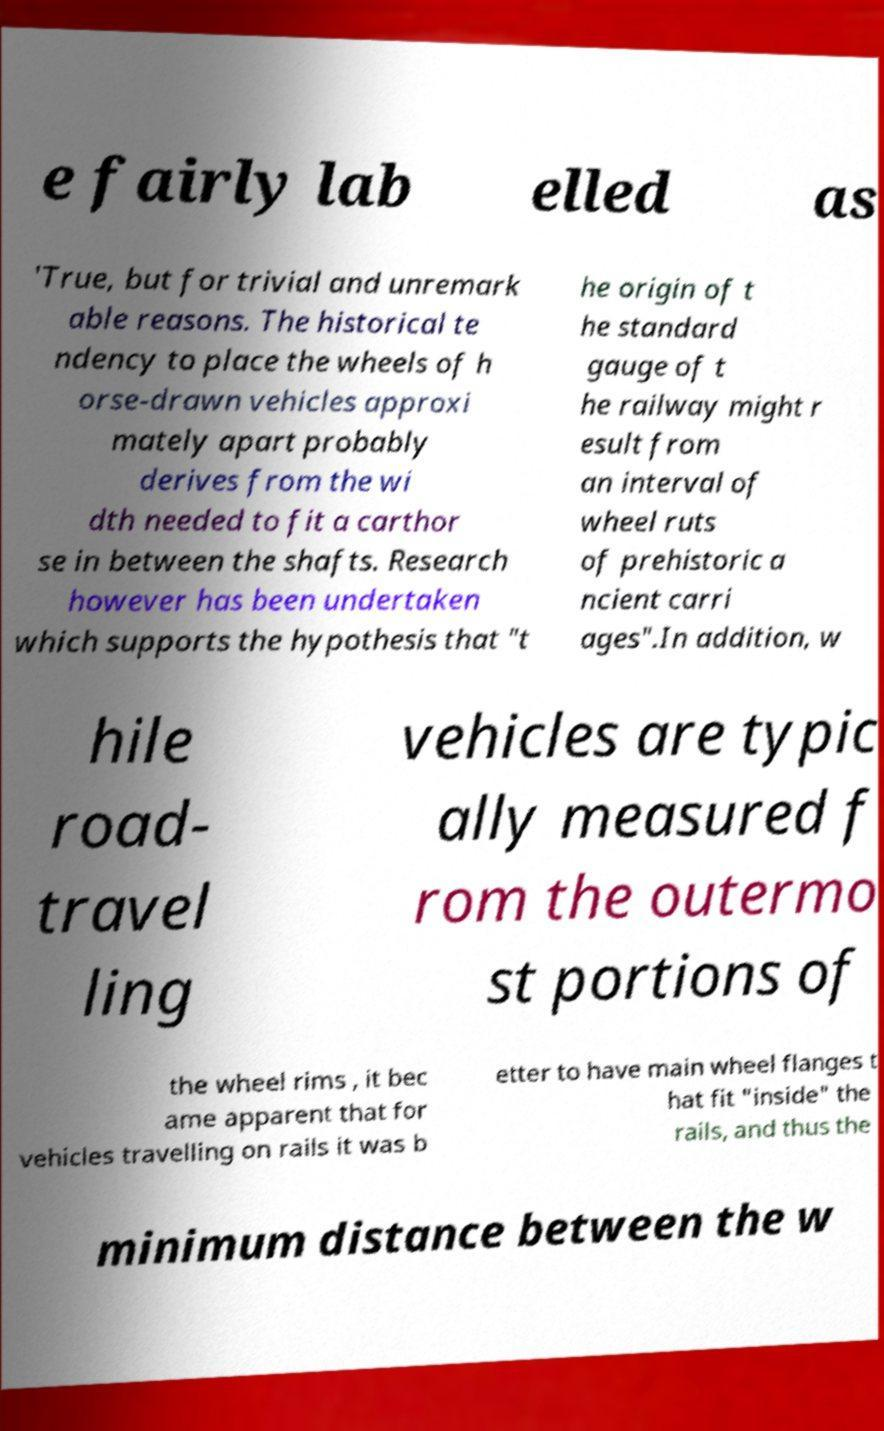For documentation purposes, I need the text within this image transcribed. Could you provide that? e fairly lab elled as 'True, but for trivial and unremark able reasons. The historical te ndency to place the wheels of h orse-drawn vehicles approxi mately apart probably derives from the wi dth needed to fit a carthor se in between the shafts. Research however has been undertaken which supports the hypothesis that "t he origin of t he standard gauge of t he railway might r esult from an interval of wheel ruts of prehistoric a ncient carri ages".In addition, w hile road- travel ling vehicles are typic ally measured f rom the outermo st portions of the wheel rims , it bec ame apparent that for vehicles travelling on rails it was b etter to have main wheel flanges t hat fit "inside" the rails, and thus the minimum distance between the w 